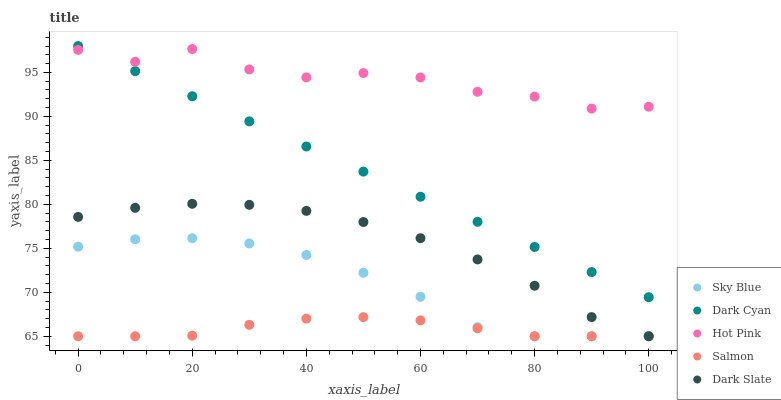Does Salmon have the minimum area under the curve?
Answer yes or no. Yes. Does Hot Pink have the maximum area under the curve?
Answer yes or no. Yes. Does Sky Blue have the minimum area under the curve?
Answer yes or no. No. Does Sky Blue have the maximum area under the curve?
Answer yes or no. No. Is Dark Cyan the smoothest?
Answer yes or no. Yes. Is Hot Pink the roughest?
Answer yes or no. Yes. Is Sky Blue the smoothest?
Answer yes or no. No. Is Sky Blue the roughest?
Answer yes or no. No. Does Sky Blue have the lowest value?
Answer yes or no. Yes. Does Hot Pink have the lowest value?
Answer yes or no. No. Does Dark Cyan have the highest value?
Answer yes or no. Yes. Does Sky Blue have the highest value?
Answer yes or no. No. Is Dark Slate less than Dark Cyan?
Answer yes or no. Yes. Is Dark Cyan greater than Salmon?
Answer yes or no. Yes. Does Dark Cyan intersect Hot Pink?
Answer yes or no. Yes. Is Dark Cyan less than Hot Pink?
Answer yes or no. No. Is Dark Cyan greater than Hot Pink?
Answer yes or no. No. Does Dark Slate intersect Dark Cyan?
Answer yes or no. No. 